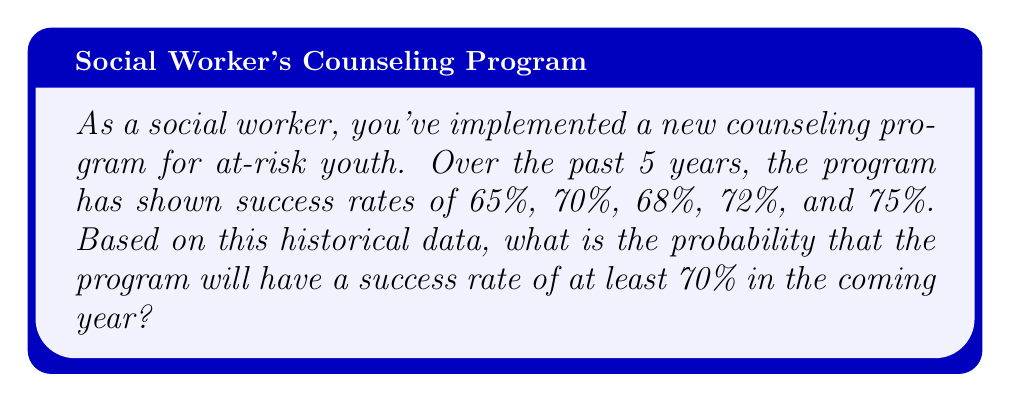Teach me how to tackle this problem. To solve this problem, we'll use the following steps:

1. Calculate the mean ($\mu$) of the historical success rates.
2. Calculate the standard deviation ($\sigma$) of the historical success rates.
3. Determine the z-score for a 70% success rate.
4. Use the z-score to find the probability of a success rate at least 70%.

Step 1: Calculate the mean
$$\mu = \frac{65\% + 70\% + 68\% + 72\% + 75\%}{5} = 70\%$$

Step 2: Calculate the standard deviation
$$\sigma = \sqrt{\frac{\sum(x_i - \mu)^2}{n-1}}$$
$$\sigma = \sqrt{\frac{(-5\%)^2 + (0\%)^2 + (-2\%)^2 + (2\%)^2 + (5\%)^2}{4}} \approx 3.81\%$$

Step 3: Determine the z-score for a 70% success rate
$$z = \frac{x - \mu}{\sigma} = \frac{70\% - 70\%}{3.81\%} = 0$$

Step 4: Use the z-score to find the probability
Since the z-score is 0, this means that 70% is exactly at the mean. In a normal distribution, half of the outcomes are above the mean. Therefore, the probability of a success rate at least 70% is 0.5 or 50%.
Answer: 0.5 